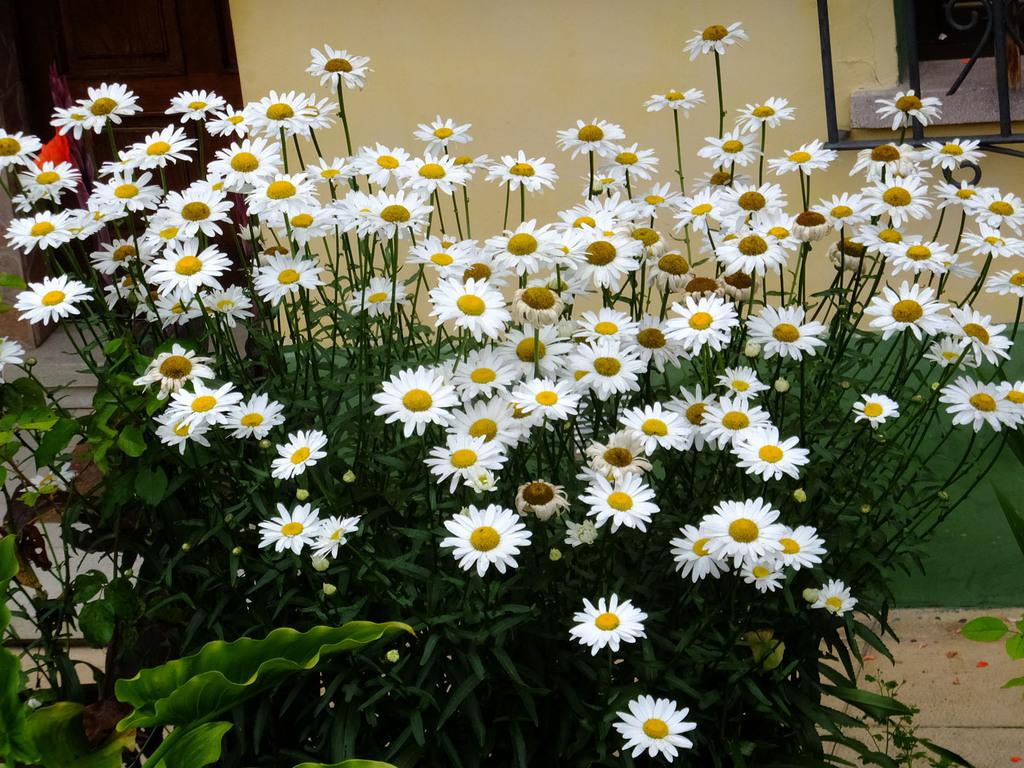What type of flora can be seen in the image? There are flowers and plants in the image. What architectural features are visible in the background of the image? There is a door, a window, and a wall in the background of the image. What is at the bottom of the image? There is a road at the bottom of the image. Can you hear the whistle of the kettle in the image? There is no kettle present in the image, so it is not possible to hear a whistle. 